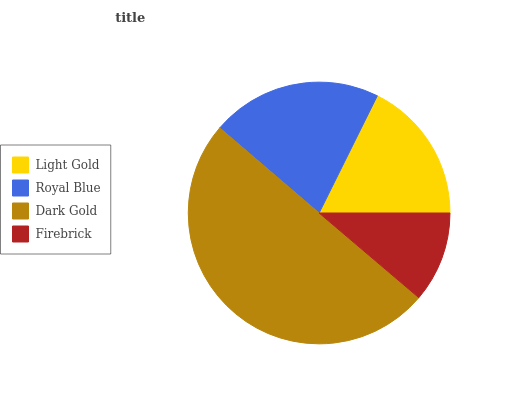Is Firebrick the minimum?
Answer yes or no. Yes. Is Dark Gold the maximum?
Answer yes or no. Yes. Is Royal Blue the minimum?
Answer yes or no. No. Is Royal Blue the maximum?
Answer yes or no. No. Is Royal Blue greater than Light Gold?
Answer yes or no. Yes. Is Light Gold less than Royal Blue?
Answer yes or no. Yes. Is Light Gold greater than Royal Blue?
Answer yes or no. No. Is Royal Blue less than Light Gold?
Answer yes or no. No. Is Royal Blue the high median?
Answer yes or no. Yes. Is Light Gold the low median?
Answer yes or no. Yes. Is Firebrick the high median?
Answer yes or no. No. Is Royal Blue the low median?
Answer yes or no. No. 